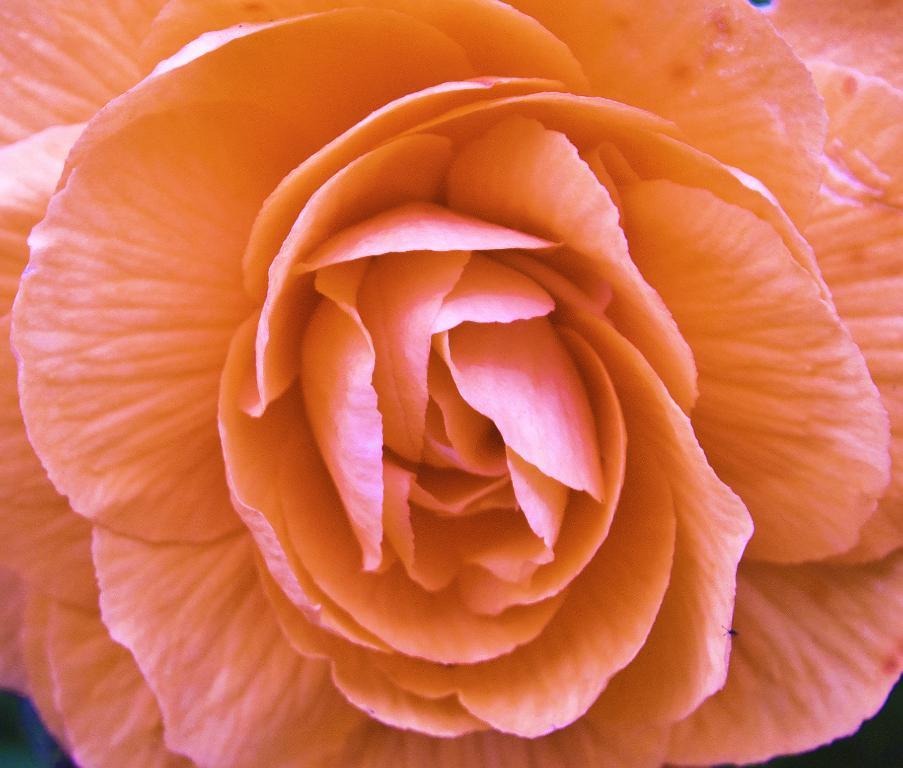How would you summarize this image in a sentence or two? In the picture I can see a flower which is in light orange color. 